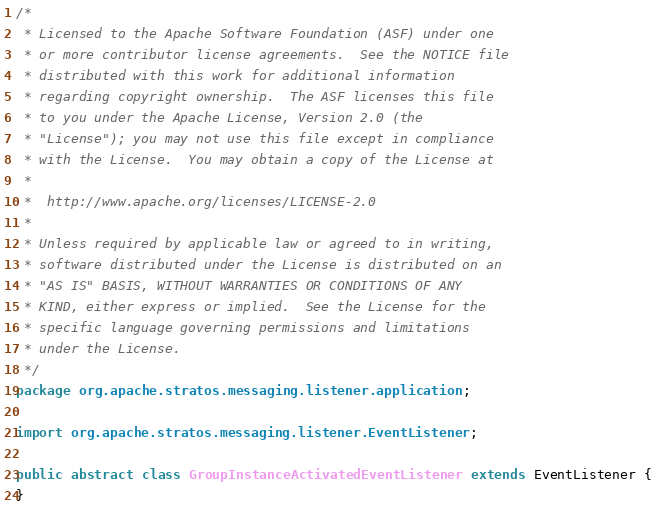Convert code to text. <code><loc_0><loc_0><loc_500><loc_500><_Java_>/*
 * Licensed to the Apache Software Foundation (ASF) under one
 * or more contributor license agreements.  See the NOTICE file
 * distributed with this work for additional information
 * regarding copyright ownership.  The ASF licenses this file
 * to you under the Apache License, Version 2.0 (the
 * "License"); you may not use this file except in compliance
 * with the License.  You may obtain a copy of the License at
 *
 *  http://www.apache.org/licenses/LICENSE-2.0
 *
 * Unless required by applicable law or agreed to in writing,
 * software distributed under the License is distributed on an
 * "AS IS" BASIS, WITHOUT WARRANTIES OR CONDITIONS OF ANY
 * KIND, either express or implied.  See the License for the
 * specific language governing permissions and limitations
 * under the License.
 */
package org.apache.stratos.messaging.listener.application;

import org.apache.stratos.messaging.listener.EventListener;

public abstract class GroupInstanceActivatedEventListener extends EventListener {
}
</code> 